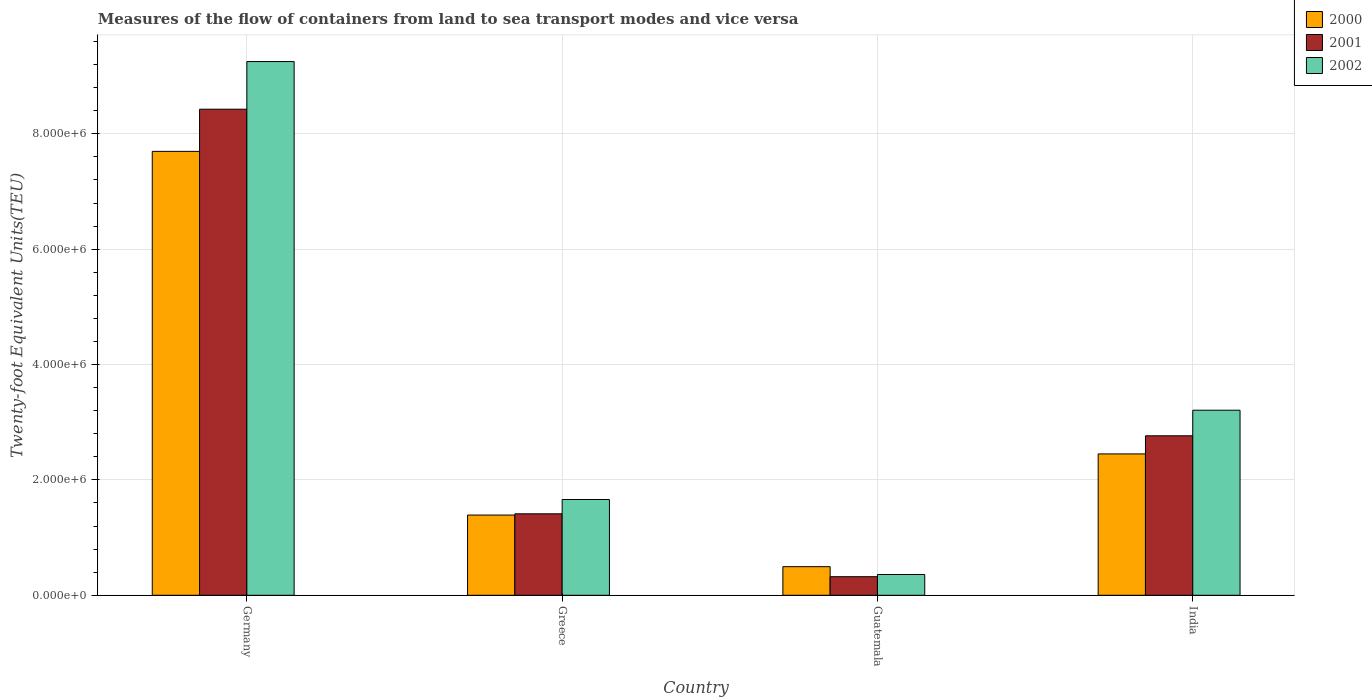How many different coloured bars are there?
Give a very brief answer. 3. Are the number of bars per tick equal to the number of legend labels?
Offer a very short reply. Yes. What is the label of the 3rd group of bars from the left?
Provide a short and direct response. Guatemala. What is the container port traffic in 2002 in Germany?
Make the answer very short. 9.25e+06. Across all countries, what is the maximum container port traffic in 2001?
Make the answer very short. 8.43e+06. Across all countries, what is the minimum container port traffic in 2001?
Make the answer very short. 3.22e+05. In which country was the container port traffic in 2000 maximum?
Your answer should be compact. Germany. In which country was the container port traffic in 2000 minimum?
Offer a very short reply. Guatemala. What is the total container port traffic in 2002 in the graph?
Ensure brevity in your answer.  1.45e+07. What is the difference between the container port traffic in 2002 in Germany and that in Guatemala?
Make the answer very short. 8.89e+06. What is the difference between the container port traffic in 2002 in Guatemala and the container port traffic in 2000 in Greece?
Ensure brevity in your answer.  -1.03e+06. What is the average container port traffic in 2002 per country?
Your answer should be very brief. 3.62e+06. What is the difference between the container port traffic of/in 2000 and container port traffic of/in 2002 in Germany?
Offer a very short reply. -1.56e+06. What is the ratio of the container port traffic in 2000 in Guatemala to that in India?
Provide a succinct answer. 0.2. Is the container port traffic in 2001 in Greece less than that in Guatemala?
Keep it short and to the point. No. Is the difference between the container port traffic in 2000 in Guatemala and India greater than the difference between the container port traffic in 2002 in Guatemala and India?
Provide a succinct answer. Yes. What is the difference between the highest and the second highest container port traffic in 2000?
Your response must be concise. 5.25e+06. What is the difference between the highest and the lowest container port traffic in 2001?
Offer a terse response. 8.10e+06. In how many countries, is the container port traffic in 2001 greater than the average container port traffic in 2001 taken over all countries?
Provide a succinct answer. 1. What does the 2nd bar from the left in India represents?
Offer a very short reply. 2001. What does the 2nd bar from the right in Germany represents?
Your answer should be very brief. 2001. How many bars are there?
Offer a very short reply. 12. Are all the bars in the graph horizontal?
Provide a short and direct response. No. How many countries are there in the graph?
Your answer should be very brief. 4. Are the values on the major ticks of Y-axis written in scientific E-notation?
Provide a short and direct response. Yes. How many legend labels are there?
Offer a terse response. 3. What is the title of the graph?
Keep it short and to the point. Measures of the flow of containers from land to sea transport modes and vice versa. Does "1965" appear as one of the legend labels in the graph?
Ensure brevity in your answer.  No. What is the label or title of the X-axis?
Offer a terse response. Country. What is the label or title of the Y-axis?
Ensure brevity in your answer.  Twenty-foot Equivalent Units(TEU). What is the Twenty-foot Equivalent Units(TEU) in 2000 in Germany?
Make the answer very short. 7.70e+06. What is the Twenty-foot Equivalent Units(TEU) in 2001 in Germany?
Ensure brevity in your answer.  8.43e+06. What is the Twenty-foot Equivalent Units(TEU) in 2002 in Germany?
Provide a succinct answer. 9.25e+06. What is the Twenty-foot Equivalent Units(TEU) of 2000 in Greece?
Ensure brevity in your answer.  1.39e+06. What is the Twenty-foot Equivalent Units(TEU) of 2001 in Greece?
Give a very brief answer. 1.41e+06. What is the Twenty-foot Equivalent Units(TEU) of 2002 in Greece?
Ensure brevity in your answer.  1.66e+06. What is the Twenty-foot Equivalent Units(TEU) of 2000 in Guatemala?
Ensure brevity in your answer.  4.96e+05. What is the Twenty-foot Equivalent Units(TEU) of 2001 in Guatemala?
Your response must be concise. 3.22e+05. What is the Twenty-foot Equivalent Units(TEU) of 2002 in Guatemala?
Keep it short and to the point. 3.60e+05. What is the Twenty-foot Equivalent Units(TEU) of 2000 in India?
Your response must be concise. 2.45e+06. What is the Twenty-foot Equivalent Units(TEU) of 2001 in India?
Offer a terse response. 2.76e+06. What is the Twenty-foot Equivalent Units(TEU) of 2002 in India?
Make the answer very short. 3.21e+06. Across all countries, what is the maximum Twenty-foot Equivalent Units(TEU) in 2000?
Your response must be concise. 7.70e+06. Across all countries, what is the maximum Twenty-foot Equivalent Units(TEU) of 2001?
Offer a terse response. 8.43e+06. Across all countries, what is the maximum Twenty-foot Equivalent Units(TEU) in 2002?
Offer a terse response. 9.25e+06. Across all countries, what is the minimum Twenty-foot Equivalent Units(TEU) in 2000?
Offer a very short reply. 4.96e+05. Across all countries, what is the minimum Twenty-foot Equivalent Units(TEU) of 2001?
Ensure brevity in your answer.  3.22e+05. Across all countries, what is the minimum Twenty-foot Equivalent Units(TEU) in 2002?
Provide a succinct answer. 3.60e+05. What is the total Twenty-foot Equivalent Units(TEU) of 2000 in the graph?
Make the answer very short. 1.20e+07. What is the total Twenty-foot Equivalent Units(TEU) of 2001 in the graph?
Your response must be concise. 1.29e+07. What is the total Twenty-foot Equivalent Units(TEU) of 2002 in the graph?
Offer a terse response. 1.45e+07. What is the difference between the Twenty-foot Equivalent Units(TEU) of 2000 in Germany and that in Greece?
Provide a succinct answer. 6.30e+06. What is the difference between the Twenty-foot Equivalent Units(TEU) in 2001 in Germany and that in Greece?
Offer a very short reply. 7.01e+06. What is the difference between the Twenty-foot Equivalent Units(TEU) of 2002 in Germany and that in Greece?
Your answer should be very brief. 7.59e+06. What is the difference between the Twenty-foot Equivalent Units(TEU) in 2000 in Germany and that in Guatemala?
Provide a short and direct response. 7.20e+06. What is the difference between the Twenty-foot Equivalent Units(TEU) of 2001 in Germany and that in Guatemala?
Offer a very short reply. 8.10e+06. What is the difference between the Twenty-foot Equivalent Units(TEU) of 2002 in Germany and that in Guatemala?
Offer a very short reply. 8.89e+06. What is the difference between the Twenty-foot Equivalent Units(TEU) of 2000 in Germany and that in India?
Your answer should be compact. 5.25e+06. What is the difference between the Twenty-foot Equivalent Units(TEU) in 2001 in Germany and that in India?
Make the answer very short. 5.66e+06. What is the difference between the Twenty-foot Equivalent Units(TEU) in 2002 in Germany and that in India?
Ensure brevity in your answer.  6.04e+06. What is the difference between the Twenty-foot Equivalent Units(TEU) in 2000 in Greece and that in Guatemala?
Provide a succinct answer. 8.95e+05. What is the difference between the Twenty-foot Equivalent Units(TEU) of 2001 in Greece and that in Guatemala?
Your answer should be compact. 1.09e+06. What is the difference between the Twenty-foot Equivalent Units(TEU) of 2002 in Greece and that in Guatemala?
Provide a succinct answer. 1.30e+06. What is the difference between the Twenty-foot Equivalent Units(TEU) in 2000 in Greece and that in India?
Your answer should be compact. -1.06e+06. What is the difference between the Twenty-foot Equivalent Units(TEU) in 2001 in Greece and that in India?
Offer a terse response. -1.35e+06. What is the difference between the Twenty-foot Equivalent Units(TEU) in 2002 in Greece and that in India?
Offer a terse response. -1.55e+06. What is the difference between the Twenty-foot Equivalent Units(TEU) of 2000 in Guatemala and that in India?
Keep it short and to the point. -1.95e+06. What is the difference between the Twenty-foot Equivalent Units(TEU) in 2001 in Guatemala and that in India?
Your answer should be compact. -2.44e+06. What is the difference between the Twenty-foot Equivalent Units(TEU) of 2002 in Guatemala and that in India?
Your answer should be very brief. -2.85e+06. What is the difference between the Twenty-foot Equivalent Units(TEU) in 2000 in Germany and the Twenty-foot Equivalent Units(TEU) in 2001 in Greece?
Offer a terse response. 6.28e+06. What is the difference between the Twenty-foot Equivalent Units(TEU) in 2000 in Germany and the Twenty-foot Equivalent Units(TEU) in 2002 in Greece?
Offer a very short reply. 6.04e+06. What is the difference between the Twenty-foot Equivalent Units(TEU) of 2001 in Germany and the Twenty-foot Equivalent Units(TEU) of 2002 in Greece?
Provide a short and direct response. 6.77e+06. What is the difference between the Twenty-foot Equivalent Units(TEU) in 2000 in Germany and the Twenty-foot Equivalent Units(TEU) in 2001 in Guatemala?
Make the answer very short. 7.37e+06. What is the difference between the Twenty-foot Equivalent Units(TEU) of 2000 in Germany and the Twenty-foot Equivalent Units(TEU) of 2002 in Guatemala?
Your response must be concise. 7.34e+06. What is the difference between the Twenty-foot Equivalent Units(TEU) in 2001 in Germany and the Twenty-foot Equivalent Units(TEU) in 2002 in Guatemala?
Provide a short and direct response. 8.07e+06. What is the difference between the Twenty-foot Equivalent Units(TEU) in 2000 in Germany and the Twenty-foot Equivalent Units(TEU) in 2001 in India?
Keep it short and to the point. 4.93e+06. What is the difference between the Twenty-foot Equivalent Units(TEU) in 2000 in Germany and the Twenty-foot Equivalent Units(TEU) in 2002 in India?
Make the answer very short. 4.49e+06. What is the difference between the Twenty-foot Equivalent Units(TEU) of 2001 in Germany and the Twenty-foot Equivalent Units(TEU) of 2002 in India?
Ensure brevity in your answer.  5.22e+06. What is the difference between the Twenty-foot Equivalent Units(TEU) of 2000 in Greece and the Twenty-foot Equivalent Units(TEU) of 2001 in Guatemala?
Your answer should be compact. 1.07e+06. What is the difference between the Twenty-foot Equivalent Units(TEU) of 2000 in Greece and the Twenty-foot Equivalent Units(TEU) of 2002 in Guatemala?
Provide a succinct answer. 1.03e+06. What is the difference between the Twenty-foot Equivalent Units(TEU) of 2001 in Greece and the Twenty-foot Equivalent Units(TEU) of 2002 in Guatemala?
Offer a terse response. 1.05e+06. What is the difference between the Twenty-foot Equivalent Units(TEU) of 2000 in Greece and the Twenty-foot Equivalent Units(TEU) of 2001 in India?
Your answer should be compact. -1.37e+06. What is the difference between the Twenty-foot Equivalent Units(TEU) of 2000 in Greece and the Twenty-foot Equivalent Units(TEU) of 2002 in India?
Ensure brevity in your answer.  -1.82e+06. What is the difference between the Twenty-foot Equivalent Units(TEU) of 2001 in Greece and the Twenty-foot Equivalent Units(TEU) of 2002 in India?
Provide a short and direct response. -1.80e+06. What is the difference between the Twenty-foot Equivalent Units(TEU) of 2000 in Guatemala and the Twenty-foot Equivalent Units(TEU) of 2001 in India?
Provide a succinct answer. -2.27e+06. What is the difference between the Twenty-foot Equivalent Units(TEU) in 2000 in Guatemala and the Twenty-foot Equivalent Units(TEU) in 2002 in India?
Provide a succinct answer. -2.71e+06. What is the difference between the Twenty-foot Equivalent Units(TEU) of 2001 in Guatemala and the Twenty-foot Equivalent Units(TEU) of 2002 in India?
Your response must be concise. -2.89e+06. What is the average Twenty-foot Equivalent Units(TEU) in 2000 per country?
Give a very brief answer. 3.01e+06. What is the average Twenty-foot Equivalent Units(TEU) of 2001 per country?
Ensure brevity in your answer.  3.23e+06. What is the average Twenty-foot Equivalent Units(TEU) of 2002 per country?
Your response must be concise. 3.62e+06. What is the difference between the Twenty-foot Equivalent Units(TEU) in 2000 and Twenty-foot Equivalent Units(TEU) in 2001 in Germany?
Your answer should be very brief. -7.31e+05. What is the difference between the Twenty-foot Equivalent Units(TEU) of 2000 and Twenty-foot Equivalent Units(TEU) of 2002 in Germany?
Ensure brevity in your answer.  -1.56e+06. What is the difference between the Twenty-foot Equivalent Units(TEU) in 2001 and Twenty-foot Equivalent Units(TEU) in 2002 in Germany?
Provide a succinct answer. -8.26e+05. What is the difference between the Twenty-foot Equivalent Units(TEU) of 2000 and Twenty-foot Equivalent Units(TEU) of 2001 in Greece?
Provide a short and direct response. -2.14e+04. What is the difference between the Twenty-foot Equivalent Units(TEU) in 2000 and Twenty-foot Equivalent Units(TEU) in 2002 in Greece?
Your answer should be very brief. -2.70e+05. What is the difference between the Twenty-foot Equivalent Units(TEU) of 2001 and Twenty-foot Equivalent Units(TEU) of 2002 in Greece?
Your answer should be compact. -2.48e+05. What is the difference between the Twenty-foot Equivalent Units(TEU) in 2000 and Twenty-foot Equivalent Units(TEU) in 2001 in Guatemala?
Ensure brevity in your answer.  1.74e+05. What is the difference between the Twenty-foot Equivalent Units(TEU) of 2000 and Twenty-foot Equivalent Units(TEU) of 2002 in Guatemala?
Ensure brevity in your answer.  1.36e+05. What is the difference between the Twenty-foot Equivalent Units(TEU) of 2001 and Twenty-foot Equivalent Units(TEU) of 2002 in Guatemala?
Provide a succinct answer. -3.80e+04. What is the difference between the Twenty-foot Equivalent Units(TEU) in 2000 and Twenty-foot Equivalent Units(TEU) in 2001 in India?
Provide a short and direct response. -3.14e+05. What is the difference between the Twenty-foot Equivalent Units(TEU) of 2000 and Twenty-foot Equivalent Units(TEU) of 2002 in India?
Offer a terse response. -7.58e+05. What is the difference between the Twenty-foot Equivalent Units(TEU) of 2001 and Twenty-foot Equivalent Units(TEU) of 2002 in India?
Provide a succinct answer. -4.44e+05. What is the ratio of the Twenty-foot Equivalent Units(TEU) in 2000 in Germany to that in Greece?
Provide a succinct answer. 5.53. What is the ratio of the Twenty-foot Equivalent Units(TEU) of 2001 in Germany to that in Greece?
Your response must be concise. 5.97. What is the ratio of the Twenty-foot Equivalent Units(TEU) in 2002 in Germany to that in Greece?
Keep it short and to the point. 5.57. What is the ratio of the Twenty-foot Equivalent Units(TEU) in 2000 in Germany to that in Guatemala?
Ensure brevity in your answer.  15.52. What is the ratio of the Twenty-foot Equivalent Units(TEU) in 2001 in Germany to that in Guatemala?
Give a very brief answer. 26.16. What is the ratio of the Twenty-foot Equivalent Units(TEU) of 2002 in Germany to that in Guatemala?
Give a very brief answer. 25.69. What is the ratio of the Twenty-foot Equivalent Units(TEU) in 2000 in Germany to that in India?
Provide a succinct answer. 3.14. What is the ratio of the Twenty-foot Equivalent Units(TEU) in 2001 in Germany to that in India?
Provide a succinct answer. 3.05. What is the ratio of the Twenty-foot Equivalent Units(TEU) in 2002 in Germany to that in India?
Offer a terse response. 2.88. What is the ratio of the Twenty-foot Equivalent Units(TEU) in 2000 in Greece to that in Guatemala?
Give a very brief answer. 2.81. What is the ratio of the Twenty-foot Equivalent Units(TEU) of 2001 in Greece to that in Guatemala?
Offer a terse response. 4.38. What is the ratio of the Twenty-foot Equivalent Units(TEU) in 2002 in Greece to that in Guatemala?
Keep it short and to the point. 4.61. What is the ratio of the Twenty-foot Equivalent Units(TEU) of 2000 in Greece to that in India?
Your answer should be compact. 0.57. What is the ratio of the Twenty-foot Equivalent Units(TEU) in 2001 in Greece to that in India?
Your answer should be very brief. 0.51. What is the ratio of the Twenty-foot Equivalent Units(TEU) of 2002 in Greece to that in India?
Your answer should be very brief. 0.52. What is the ratio of the Twenty-foot Equivalent Units(TEU) in 2000 in Guatemala to that in India?
Give a very brief answer. 0.2. What is the ratio of the Twenty-foot Equivalent Units(TEU) of 2001 in Guatemala to that in India?
Provide a succinct answer. 0.12. What is the ratio of the Twenty-foot Equivalent Units(TEU) in 2002 in Guatemala to that in India?
Provide a short and direct response. 0.11. What is the difference between the highest and the second highest Twenty-foot Equivalent Units(TEU) of 2000?
Make the answer very short. 5.25e+06. What is the difference between the highest and the second highest Twenty-foot Equivalent Units(TEU) in 2001?
Keep it short and to the point. 5.66e+06. What is the difference between the highest and the second highest Twenty-foot Equivalent Units(TEU) in 2002?
Offer a terse response. 6.04e+06. What is the difference between the highest and the lowest Twenty-foot Equivalent Units(TEU) in 2000?
Your answer should be compact. 7.20e+06. What is the difference between the highest and the lowest Twenty-foot Equivalent Units(TEU) in 2001?
Offer a terse response. 8.10e+06. What is the difference between the highest and the lowest Twenty-foot Equivalent Units(TEU) in 2002?
Your response must be concise. 8.89e+06. 